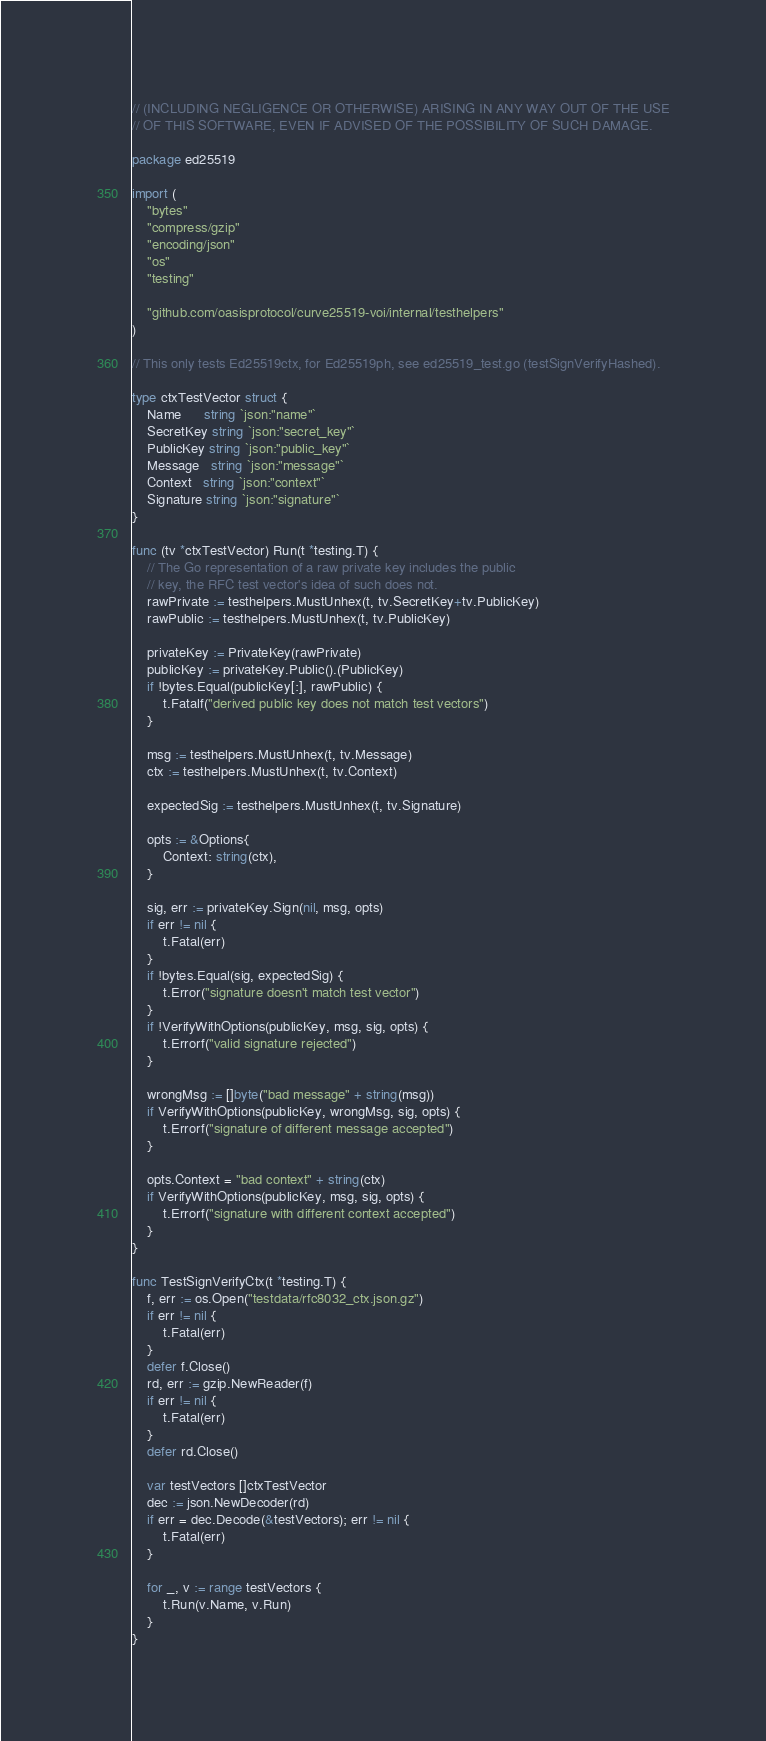<code> <loc_0><loc_0><loc_500><loc_500><_Go_>// (INCLUDING NEGLIGENCE OR OTHERWISE) ARISING IN ANY WAY OUT OF THE USE
// OF THIS SOFTWARE, EVEN IF ADVISED OF THE POSSIBILITY OF SUCH DAMAGE.

package ed25519

import (
	"bytes"
	"compress/gzip"
	"encoding/json"
	"os"
	"testing"

	"github.com/oasisprotocol/curve25519-voi/internal/testhelpers"
)

// This only tests Ed25519ctx, for Ed25519ph, see ed25519_test.go (testSignVerifyHashed).

type ctxTestVector struct {
	Name      string `json:"name"`
	SecretKey string `json:"secret_key"`
	PublicKey string `json:"public_key"`
	Message   string `json:"message"`
	Context   string `json:"context"`
	Signature string `json:"signature"`
}

func (tv *ctxTestVector) Run(t *testing.T) {
	// The Go representation of a raw private key includes the public
	// key, the RFC test vector's idea of such does not.
	rawPrivate := testhelpers.MustUnhex(t, tv.SecretKey+tv.PublicKey)
	rawPublic := testhelpers.MustUnhex(t, tv.PublicKey)

	privateKey := PrivateKey(rawPrivate)
	publicKey := privateKey.Public().(PublicKey)
	if !bytes.Equal(publicKey[:], rawPublic) {
		t.Fatalf("derived public key does not match test vectors")
	}

	msg := testhelpers.MustUnhex(t, tv.Message)
	ctx := testhelpers.MustUnhex(t, tv.Context)

	expectedSig := testhelpers.MustUnhex(t, tv.Signature)

	opts := &Options{
		Context: string(ctx),
	}

	sig, err := privateKey.Sign(nil, msg, opts)
	if err != nil {
		t.Fatal(err)
	}
	if !bytes.Equal(sig, expectedSig) {
		t.Error("signature doesn't match test vector")
	}
	if !VerifyWithOptions(publicKey, msg, sig, opts) {
		t.Errorf("valid signature rejected")
	}

	wrongMsg := []byte("bad message" + string(msg))
	if VerifyWithOptions(publicKey, wrongMsg, sig, opts) {
		t.Errorf("signature of different message accepted")
	}

	opts.Context = "bad context" + string(ctx)
	if VerifyWithOptions(publicKey, msg, sig, opts) {
		t.Errorf("signature with different context accepted")
	}
}

func TestSignVerifyCtx(t *testing.T) {
	f, err := os.Open("testdata/rfc8032_ctx.json.gz")
	if err != nil {
		t.Fatal(err)
	}
	defer f.Close()
	rd, err := gzip.NewReader(f)
	if err != nil {
		t.Fatal(err)
	}
	defer rd.Close()

	var testVectors []ctxTestVector
	dec := json.NewDecoder(rd)
	if err = dec.Decode(&testVectors); err != nil {
		t.Fatal(err)
	}

	for _, v := range testVectors {
		t.Run(v.Name, v.Run)
	}
}
</code> 